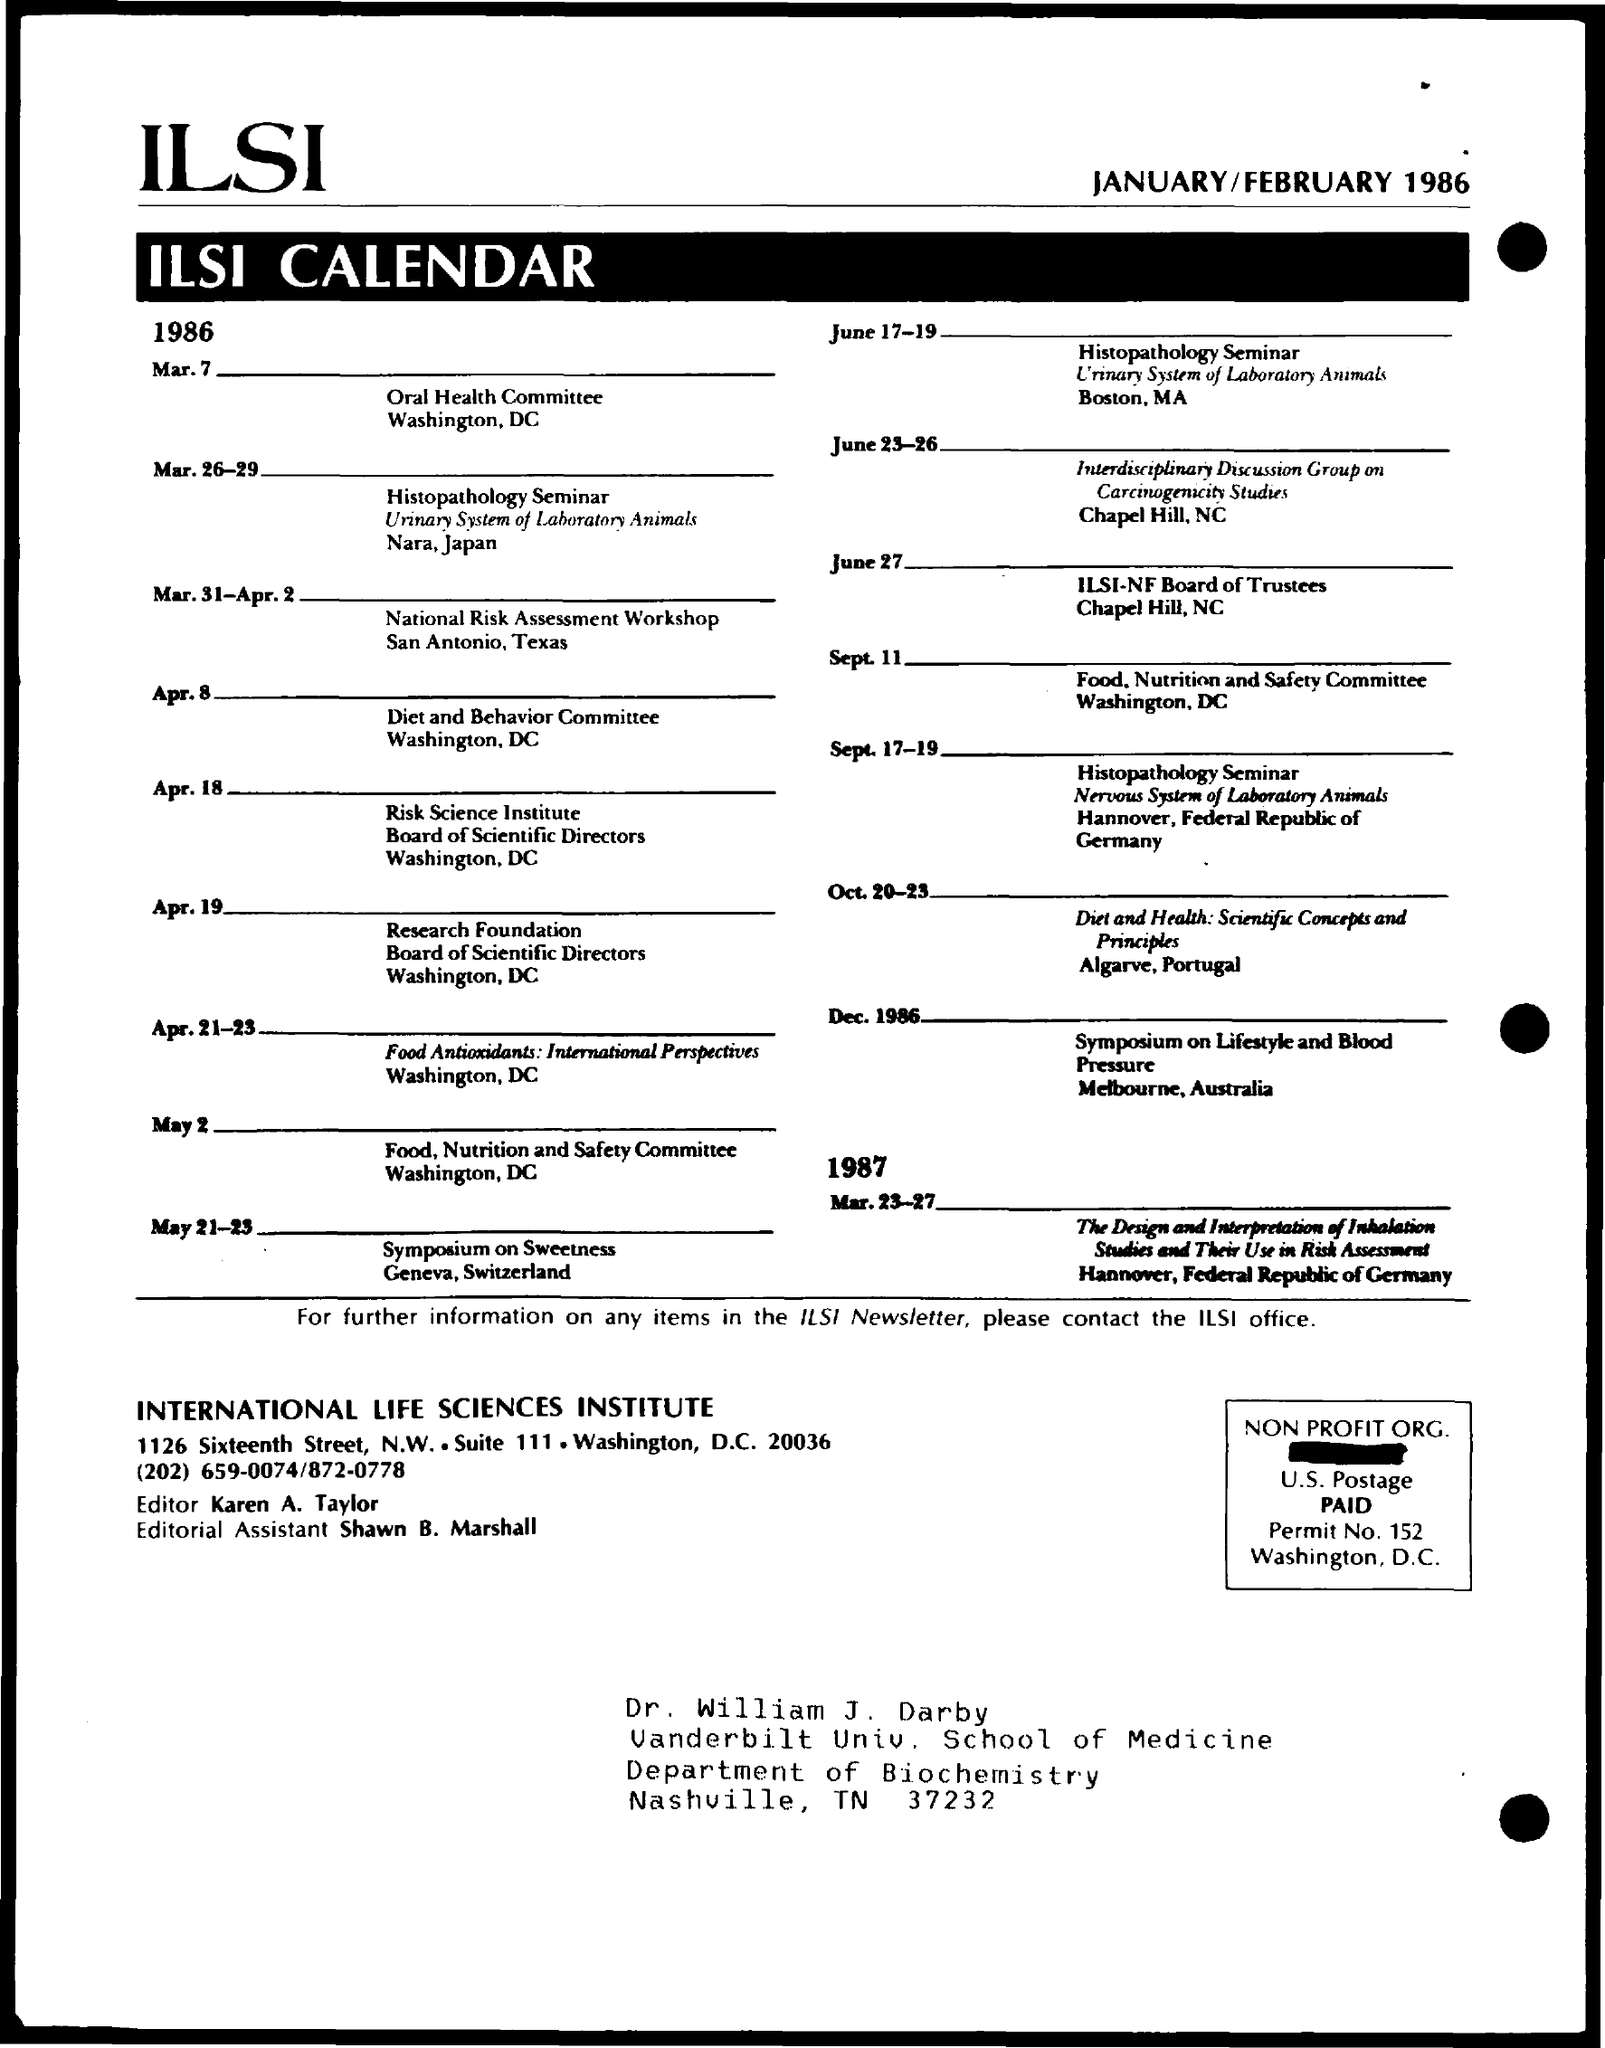What is the first title in the document?
Provide a short and direct response. Ilsi. What is the second title in the document?
Offer a terse response. Ilsi calendar. Who is the editor?
Offer a very short reply. Karen a. taylor. Who is the editorial assistant?
Your answer should be compact. Shawn b. marshall. What is the permit number?
Give a very brief answer. 152. 